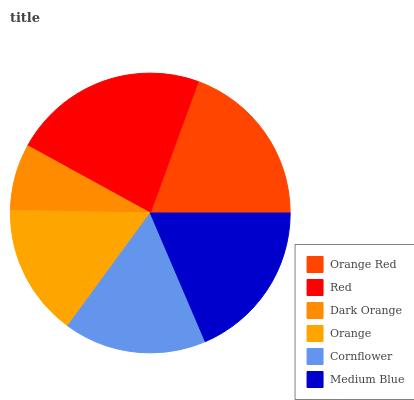Is Dark Orange the minimum?
Answer yes or no. Yes. Is Red the maximum?
Answer yes or no. Yes. Is Red the minimum?
Answer yes or no. No. Is Dark Orange the maximum?
Answer yes or no. No. Is Red greater than Dark Orange?
Answer yes or no. Yes. Is Dark Orange less than Red?
Answer yes or no. Yes. Is Dark Orange greater than Red?
Answer yes or no. No. Is Red less than Dark Orange?
Answer yes or no. No. Is Medium Blue the high median?
Answer yes or no. Yes. Is Cornflower the low median?
Answer yes or no. Yes. Is Orange the high median?
Answer yes or no. No. Is Orange the low median?
Answer yes or no. No. 